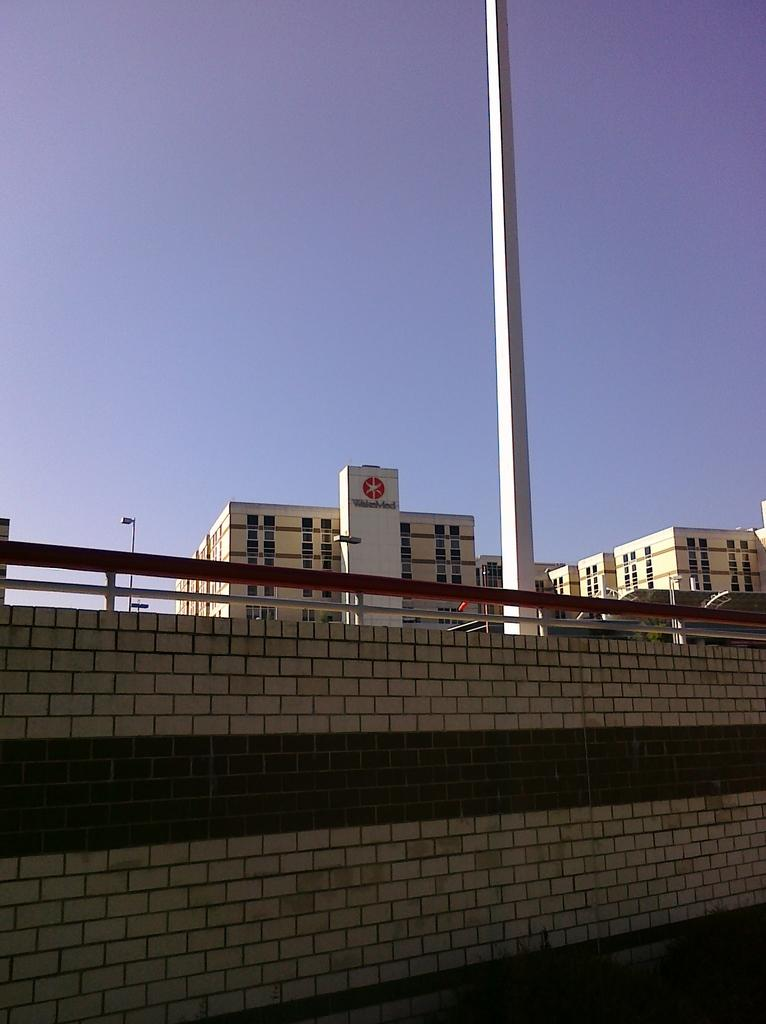What type of structures can be seen in the image? There are buildings in the image. Can you describe any specific features on the buildings? There is text on the wall of a building, and it says "polite." What else can be seen in the image besides the buildings? There is a wall, a pole, and the sky in the image. What color is the sky in the image? The sky is blue in the image. What type of balloon can be seen floating near the buildings in the image? There is no balloon present in the image. What is the growth rate of the teeth on the wall in the image? There are no teeth present in the image, so it is not possible to determine their growth rate. 